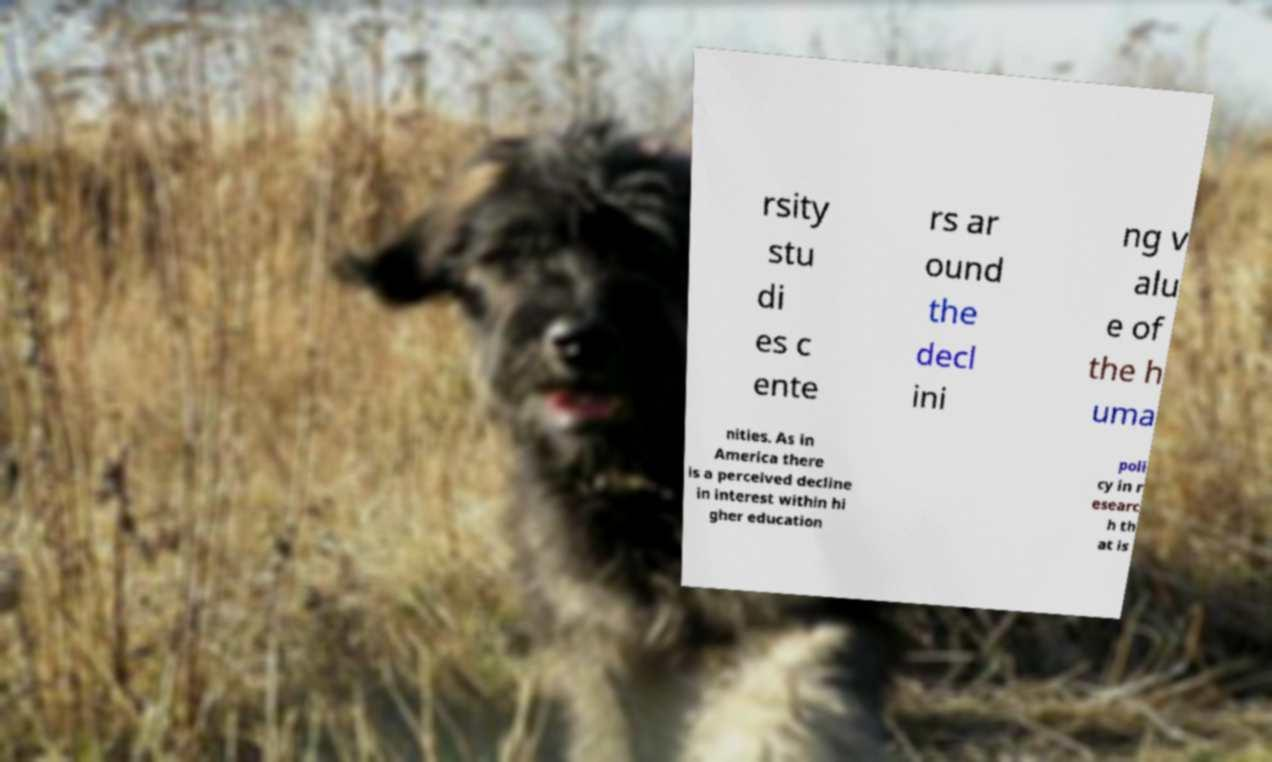What messages or text are displayed in this image? I need them in a readable, typed format. rsity stu di es c ente rs ar ound the decl ini ng v alu e of the h uma nities. As in America there is a perceived decline in interest within hi gher education poli cy in r esearc h th at is 